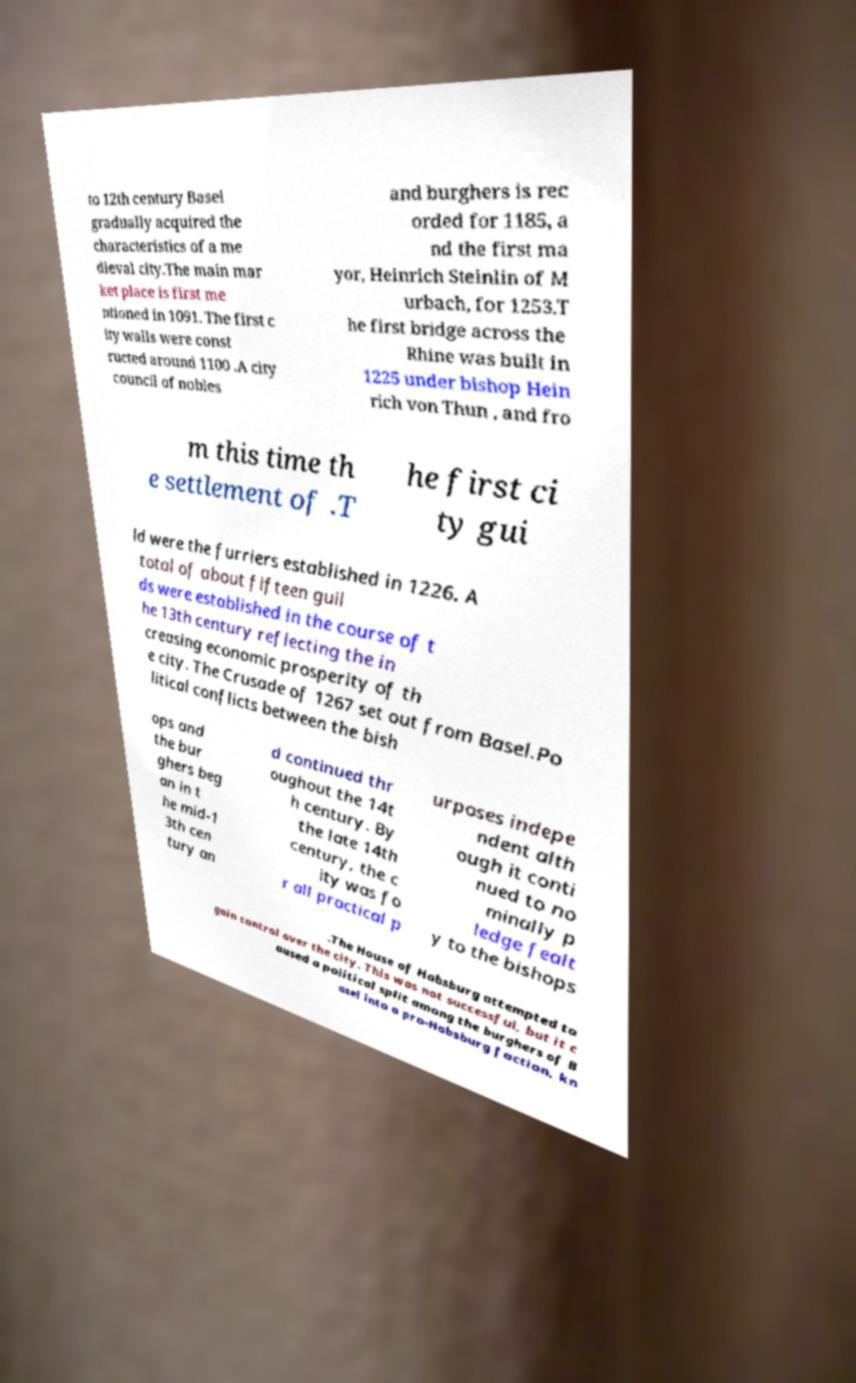There's text embedded in this image that I need extracted. Can you transcribe it verbatim? to 12th century Basel gradually acquired the characteristics of a me dieval city.The main mar ket place is first me ntioned in 1091. The first c ity walls were const ructed around 1100 .A city council of nobles and burghers is rec orded for 1185, a nd the first ma yor, Heinrich Steinlin of M urbach, for 1253.T he first bridge across the Rhine was built in 1225 under bishop Hein rich von Thun , and fro m this time th e settlement of .T he first ci ty gui ld were the furriers established in 1226. A total of about fifteen guil ds were established in the course of t he 13th century reflecting the in creasing economic prosperity of th e city. The Crusade of 1267 set out from Basel.Po litical conflicts between the bish ops and the bur ghers beg an in t he mid-1 3th cen tury an d continued thr oughout the 14t h century. By the late 14th century, the c ity was fo r all practical p urposes indepe ndent alth ough it conti nued to no minally p ledge fealt y to the bishops .The House of Habsburg attempted to gain control over the city. This was not successful, but it c aused a political split among the burghers of B asel into a pro-Habsburg faction, kn 